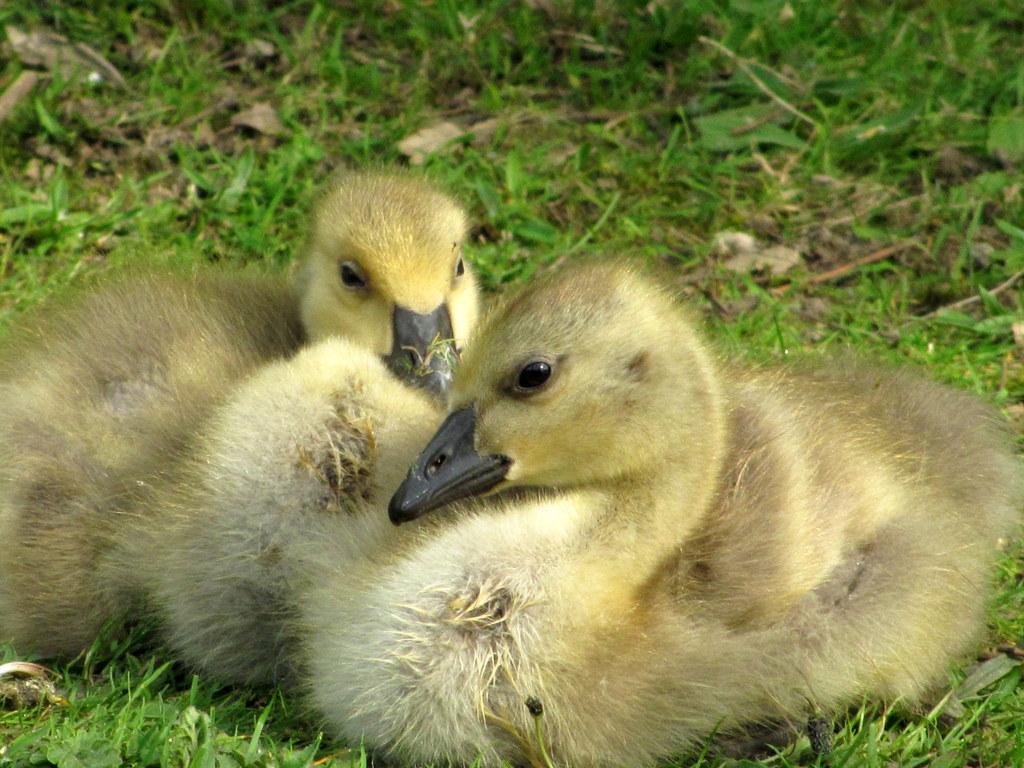Can you describe this image briefly? In this image we can see two ducks, also we can see the grass. 